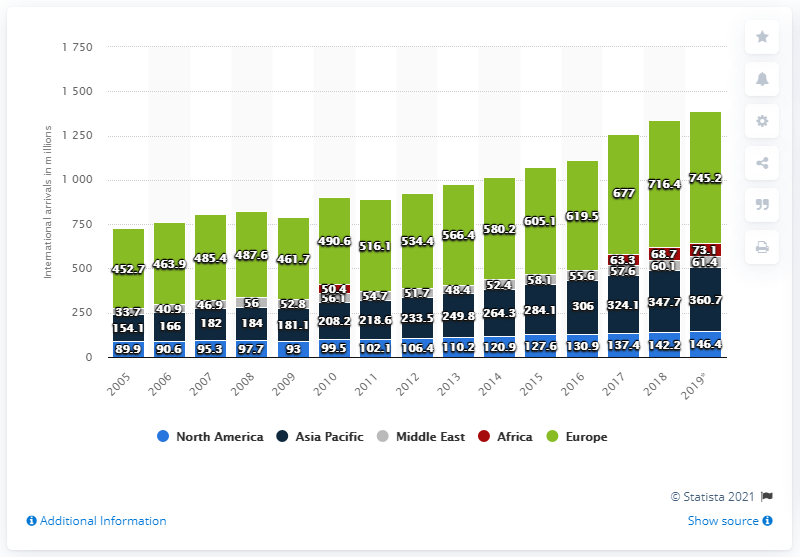Indicate a few pertinent items in this graphic. In 2019, there were 61.4 million international tourist arrivals in the Middle East. In 2019, there were 146.4 million international tourist arrivals in North America. 